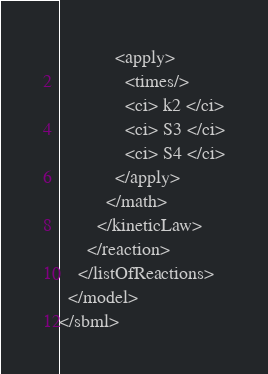<code> <loc_0><loc_0><loc_500><loc_500><_XML_>            <apply>
              <times/>
              <ci> k2 </ci>
              <ci> S3 </ci>
              <ci> S4 </ci>
            </apply>
          </math>
        </kineticLaw>
      </reaction>
    </listOfReactions>
  </model>
</sbml>
</code> 